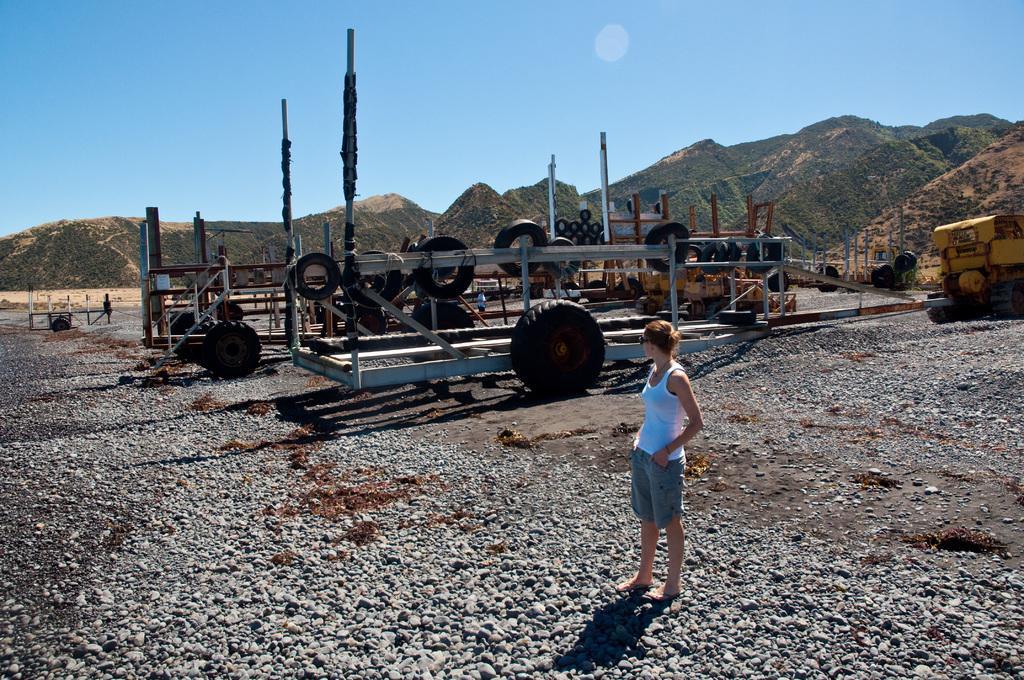Please provide a concise description of this image. Here a beautiful woman is standing, she wore white color top and looking at that side, there are vehicles at here. At the long back side there are hills, at the top it's a sky. 